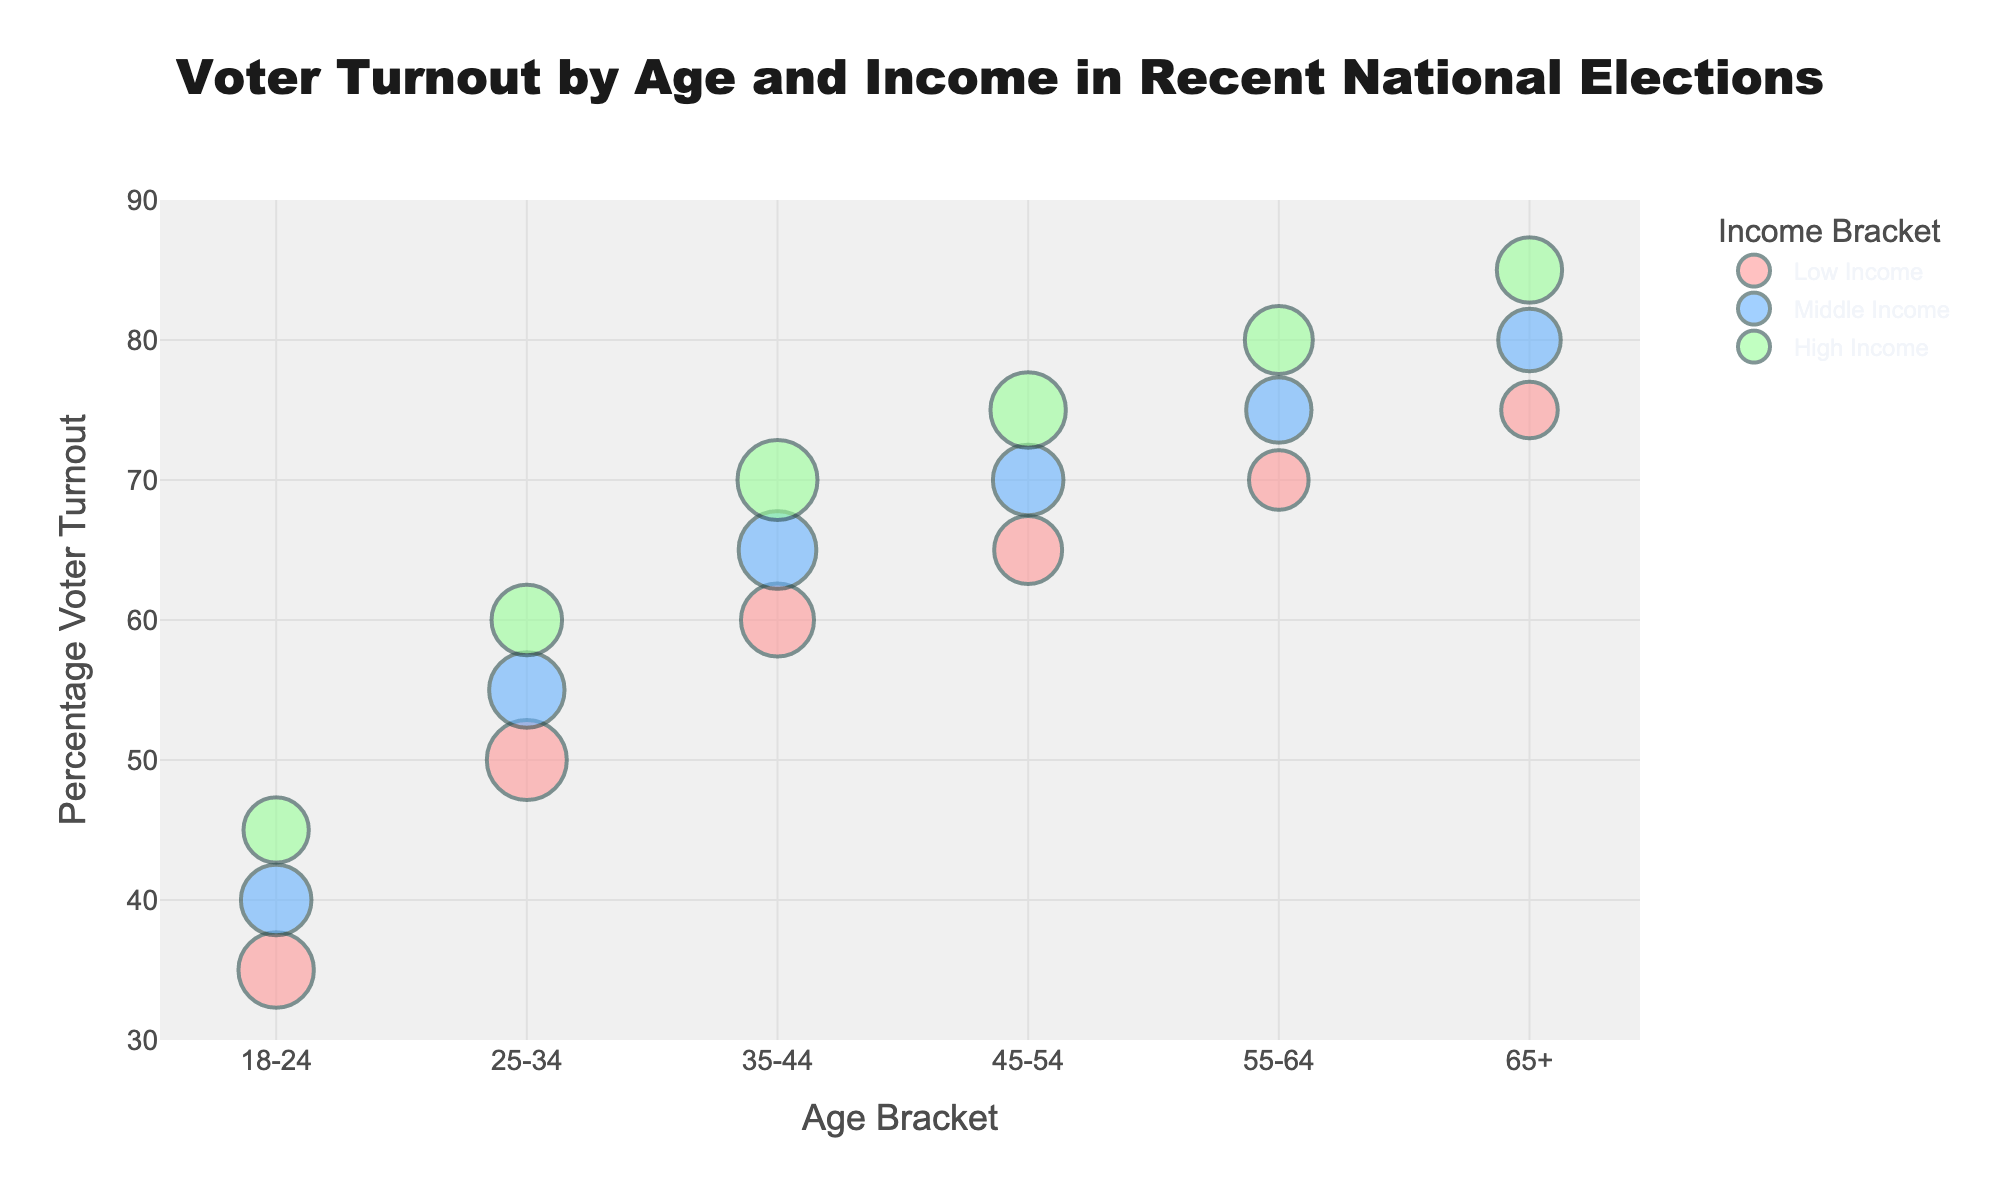What's the title of the figure? The title is often placed prominently at the top center of the figure. It provides a brief summary of what the entire figure is about. Here, the title reads "Voter Turnout by Age and Income in Recent National Elections."
Answer: Voter Turnout by Age and Income in Recent National Elections What does the x-axis represent? The information on the x-axis is clearly labeled, usually at the bottom of the figure, showing what it measures. In this figure, the x-axis represents "Age Bracket."
Answer: Age Bracket What does the y-axis represent? The y-axis label is placed vertically along the left side of the figure and indicates what is being measured on this axis. Here, the y-axis represents "Percentage Voter Turnout."
Answer: Percentage Voter Turnout Which age bracket and income bracket combination has the highest voter turnout? To determine this, look for the highest y-axis value in the entire figure and check which color-coded bubble it corresponds to. The highest y-axis value is 85%, which occurs in the 65+ age bracket with high income.
Answer: 65+, High Income What is the relationship between income level and voter turnout within the 25-34 age bracket? Analyze the trend of the bubbles within the 25-34 age bracket along the y-axis. The voter turnout increases from low income (50%) to middle income (55%) and then to high income (60%).
Answer: Higher income correlates with higher voter turnout How does the size of the bubbles reflect the segment size? The size of each bubble represents the segment size, with larger bubbles indicating larger voter segments. For example, the bubble sizes for the low-income segment in the 25-34 age bracket is larger compared to the high-income segment.
Answer: Larger bubbles indicate larger voter segments What is the voter turnout percentage for middle-income voters aged 55-64? Look at the bubble corresponding to the middle-income group in the 55-64 age bracket and read off the y-axis value. The voter turnout for this segment is 75%.
Answer: 75% Compare the voter turnout for low-income voters aged 18-24 to high-income voters aged 45-54. Locate the bubbles for these categories and compare their y-axis positions. Low-income voters aged 18-24 have a turnout of 35%, while high-income voters aged 45-54 have a turnout of 75%.
Answer: 35% vs. 75% Which income group seems to have the most consistently high voter turnout across all age brackets? Examine the trend lines formed by the bubbles across all age brackets. The high-income group consistently has higher voter turnout percentages in each age bracket compared to low and middle-income groups.
Answer: High Income What is the largest voter segment size shown in the figure? Compare the sizes of the bubbles across the entire figure. The largest segment size corresponds to a bubble size of 9 million in the low-income group of the 25-34 age bracket.
Answer: 9 million 